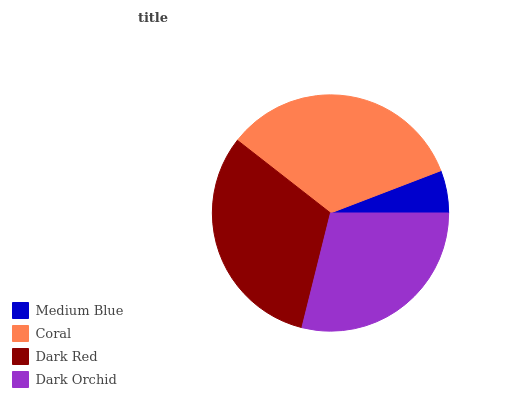Is Medium Blue the minimum?
Answer yes or no. Yes. Is Coral the maximum?
Answer yes or no. Yes. Is Dark Red the minimum?
Answer yes or no. No. Is Dark Red the maximum?
Answer yes or no. No. Is Coral greater than Dark Red?
Answer yes or no. Yes. Is Dark Red less than Coral?
Answer yes or no. Yes. Is Dark Red greater than Coral?
Answer yes or no. No. Is Coral less than Dark Red?
Answer yes or no. No. Is Dark Red the high median?
Answer yes or no. Yes. Is Dark Orchid the low median?
Answer yes or no. Yes. Is Medium Blue the high median?
Answer yes or no. No. Is Medium Blue the low median?
Answer yes or no. No. 